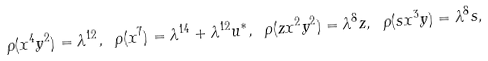Convert formula to latex. <formula><loc_0><loc_0><loc_500><loc_500>\rho ( x ^ { 4 } y ^ { 2 } ) = \lambda ^ { 1 2 } , \ \rho ( x ^ { 7 } ) = \lambda ^ { 1 4 } + \lambda ^ { 1 2 } u ^ { * } , \ \rho ( z x ^ { 2 } y ^ { 2 } ) = \lambda ^ { 8 } z , \ \rho ( s x ^ { 3 } y ) = \lambda ^ { 8 } s ,</formula> 